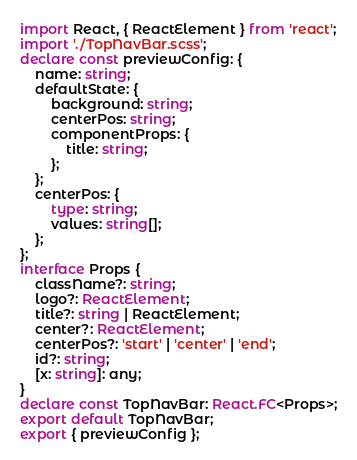Convert code to text. <code><loc_0><loc_0><loc_500><loc_500><_TypeScript_>import React, { ReactElement } from 'react';
import './TopNavBar.scss';
declare const previewConfig: {
    name: string;
    defaultState: {
        background: string;
        centerPos: string;
        componentProps: {
            title: string;
        };
    };
    centerPos: {
        type: string;
        values: string[];
    };
};
interface Props {
    className?: string;
    logo?: ReactElement;
    title?: string | ReactElement;
    center?: ReactElement;
    centerPos?: 'start' | 'center' | 'end';
    id?: string;
    [x: string]: any;
}
declare const TopNavBar: React.FC<Props>;
export default TopNavBar;
export { previewConfig };
</code> 